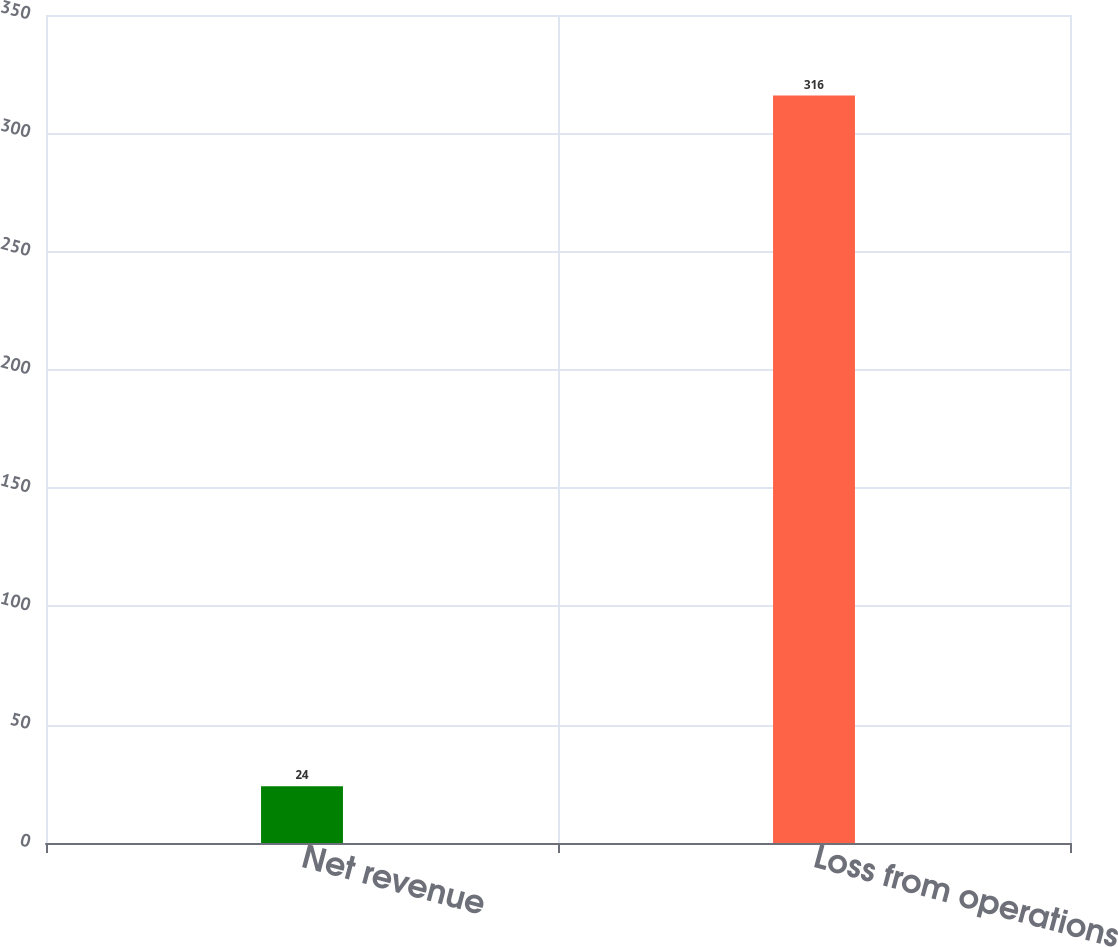<chart> <loc_0><loc_0><loc_500><loc_500><bar_chart><fcel>Net revenue<fcel>Loss from operations<nl><fcel>24<fcel>316<nl></chart> 